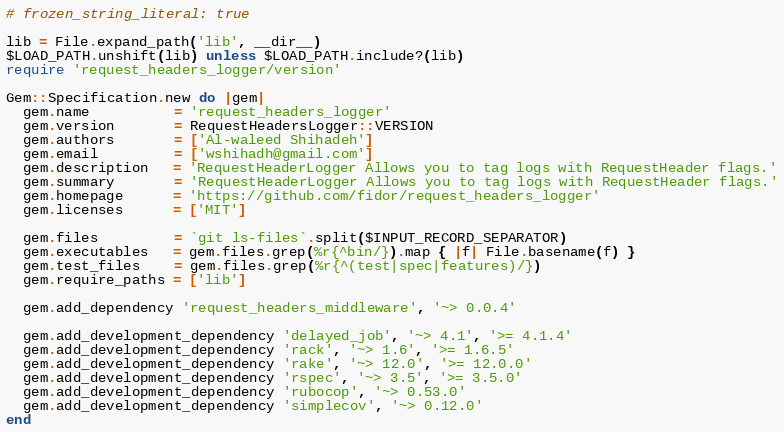<code> <loc_0><loc_0><loc_500><loc_500><_Ruby_># frozen_string_literal: true

lib = File.expand_path('lib', __dir__)
$LOAD_PATH.unshift(lib) unless $LOAD_PATH.include?(lib)
require 'request_headers_logger/version'

Gem::Specification.new do |gem|
  gem.name          = 'request_headers_logger'
  gem.version       = RequestHeadersLogger::VERSION
  gem.authors       = ['Al-waleed Shihadeh']
  gem.email         = ['wshihadh@gmail.com']
  gem.description   = 'RequestHeaderLogger Allows you to tag logs with RequestHeader flags.'
  gem.summary       = 'RequestHeaderLogger Allows you to tag logs with RequestHeader flags.'
  gem.homepage      = 'https://github.com/fidor/request_headers_logger'
  gem.licenses      = ['MIT']

  gem.files         = `git ls-files`.split($INPUT_RECORD_SEPARATOR)
  gem.executables   = gem.files.grep(%r{^bin/}).map { |f| File.basename(f) }
  gem.test_files    = gem.files.grep(%r{^(test|spec|features)/})
  gem.require_paths = ['lib']

  gem.add_dependency 'request_headers_middleware', '~> 0.0.4'

  gem.add_development_dependency 'delayed_job', '~> 4.1', '>= 4.1.4'
  gem.add_development_dependency 'rack', '~> 1.6', '>= 1.6.5'
  gem.add_development_dependency 'rake', '~> 12.0', '>= 12.0.0'
  gem.add_development_dependency 'rspec', '~> 3.5', '>= 3.5.0'
  gem.add_development_dependency 'rubocop', '~> 0.53.0'
  gem.add_development_dependency 'simplecov', '~> 0.12.0'
end
</code> 